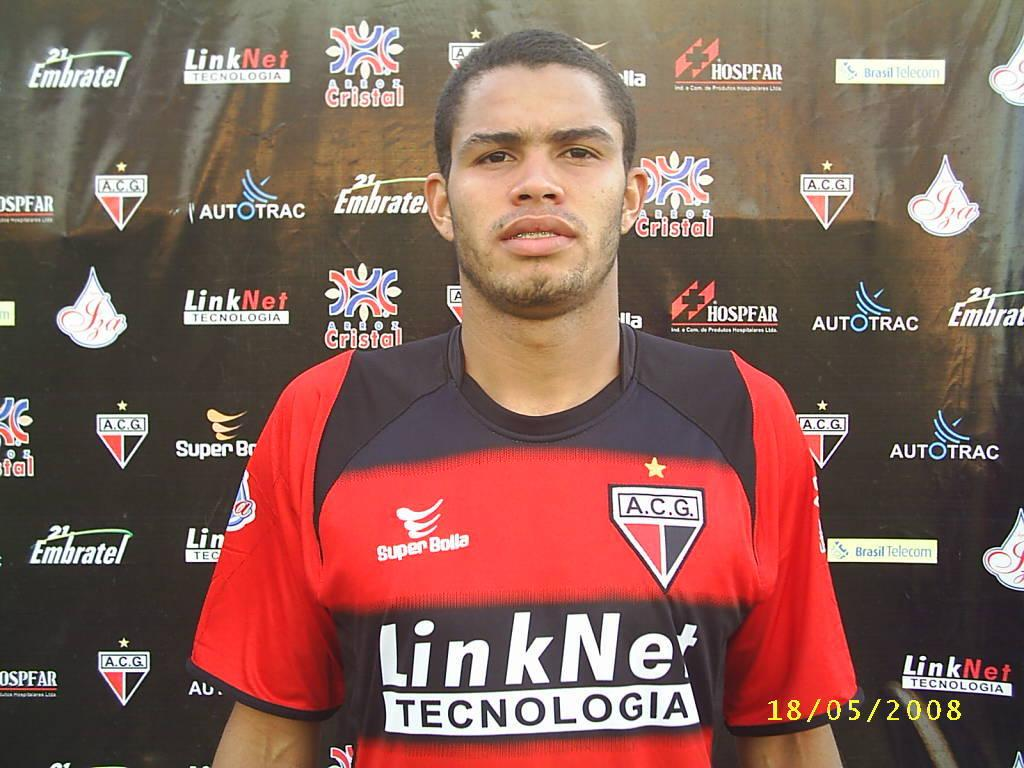<image>
Create a compact narrative representing the image presented. Soccer player playing for the team A.C.G. posing in front of advertisements. 